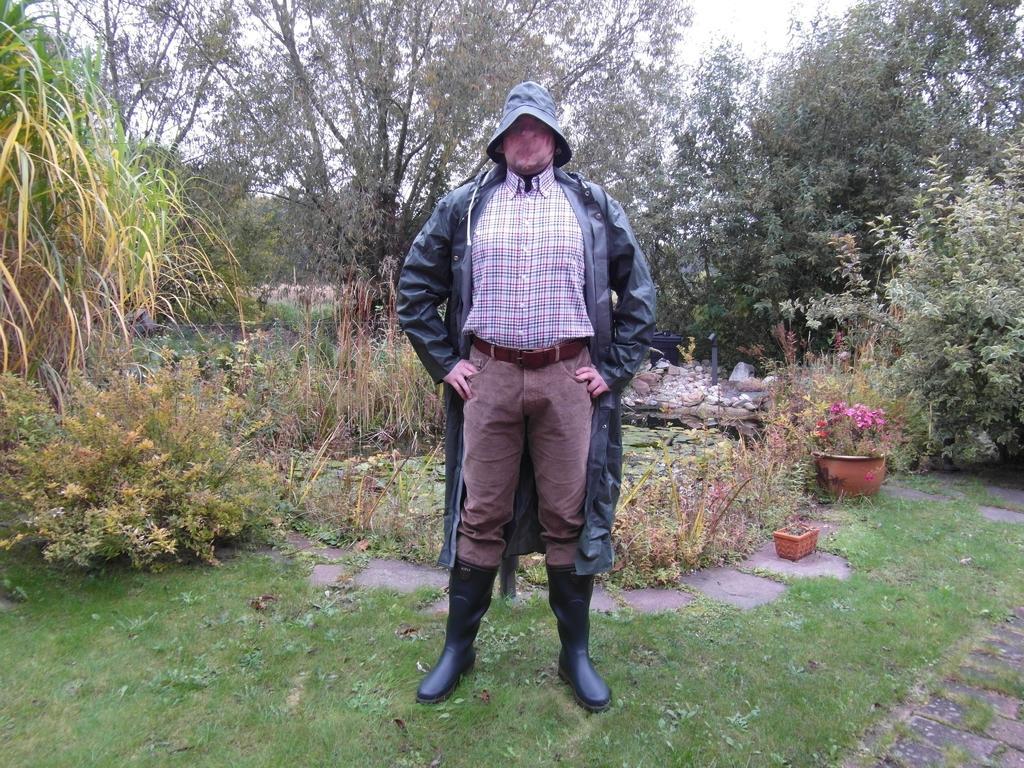Describe this image in one or two sentences. In this picture we can see a man in the black jacket is standing on the grass. Behind the man there are plants, pots, trees and the sky. 